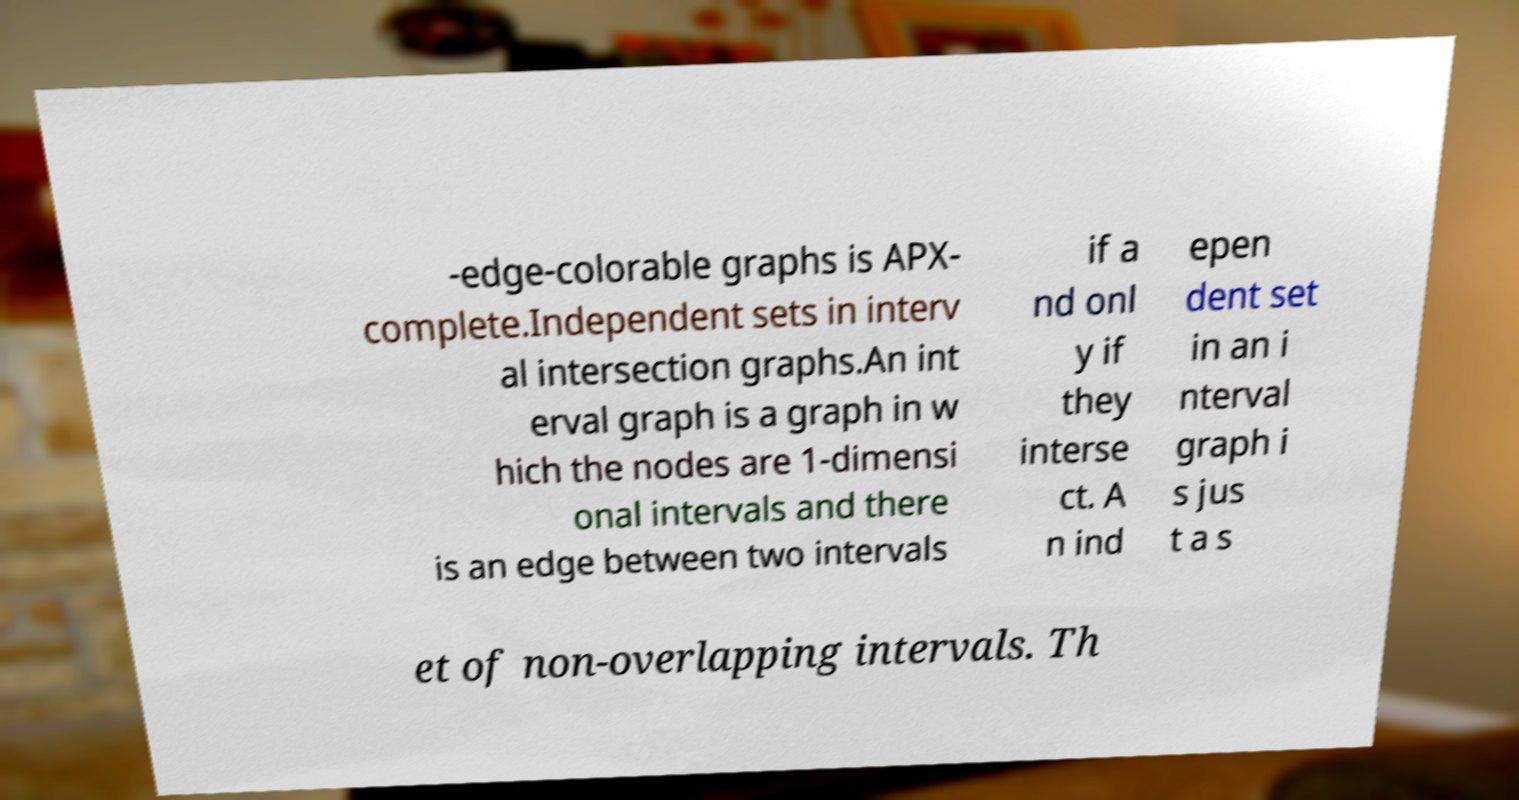I need the written content from this picture converted into text. Can you do that? -edge-colorable graphs is APX- complete.Independent sets in interv al intersection graphs.An int erval graph is a graph in w hich the nodes are 1-dimensi onal intervals and there is an edge between two intervals if a nd onl y if they interse ct. A n ind epen dent set in an i nterval graph i s jus t a s et of non-overlapping intervals. Th 